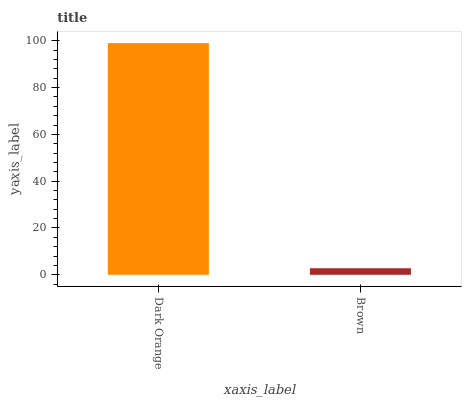Is Brown the maximum?
Answer yes or no. No. Is Dark Orange greater than Brown?
Answer yes or no. Yes. Is Brown less than Dark Orange?
Answer yes or no. Yes. Is Brown greater than Dark Orange?
Answer yes or no. No. Is Dark Orange less than Brown?
Answer yes or no. No. Is Dark Orange the high median?
Answer yes or no. Yes. Is Brown the low median?
Answer yes or no. Yes. Is Brown the high median?
Answer yes or no. No. Is Dark Orange the low median?
Answer yes or no. No. 